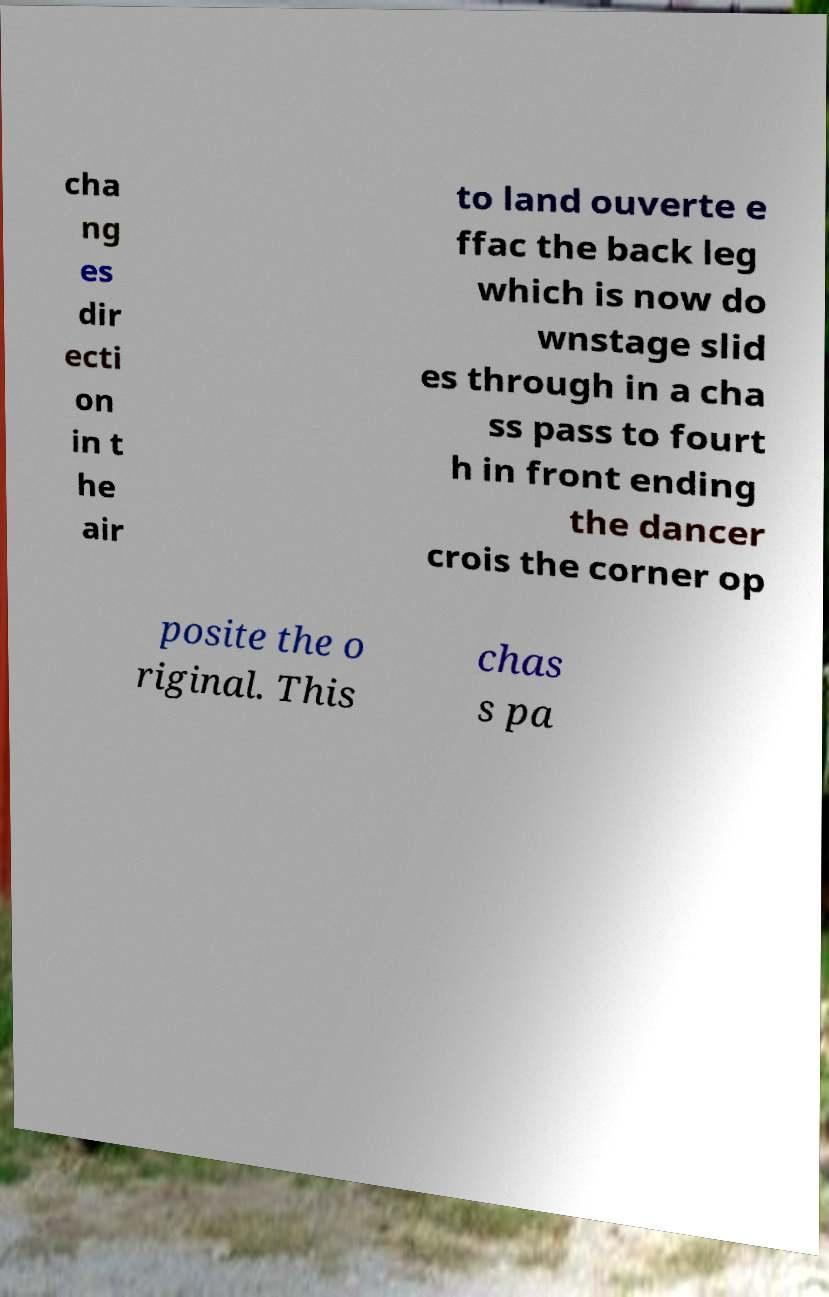There's text embedded in this image that I need extracted. Can you transcribe it verbatim? cha ng es dir ecti on in t he air to land ouverte e ffac the back leg which is now do wnstage slid es through in a cha ss pass to fourt h in front ending the dancer crois the corner op posite the o riginal. This chas s pa 